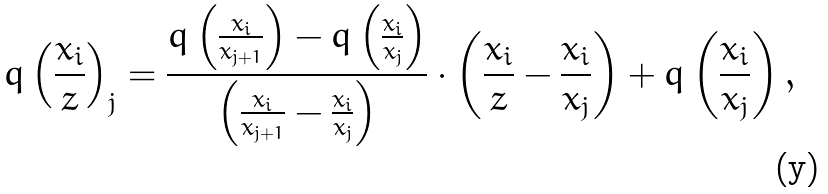<formula> <loc_0><loc_0><loc_500><loc_500>q \left ( \frac { x _ { i } } { z } \right ) _ { j } = \frac { q \left ( \frac { x _ { i } } { x _ { j + 1 } } \right ) - q \left ( \frac { x _ { i } } { x _ { j } } \right ) } { \left ( \frac { x _ { i } } { x _ { j + 1 } } - \frac { x _ { i } } { x _ { j } } \right ) } \cdot \left ( \frac { x _ { i } } { z } - \frac { x _ { i } } { x _ { j } } \right ) + q \left ( \frac { x _ { i } } { x _ { j } } \right ) ,</formula> 